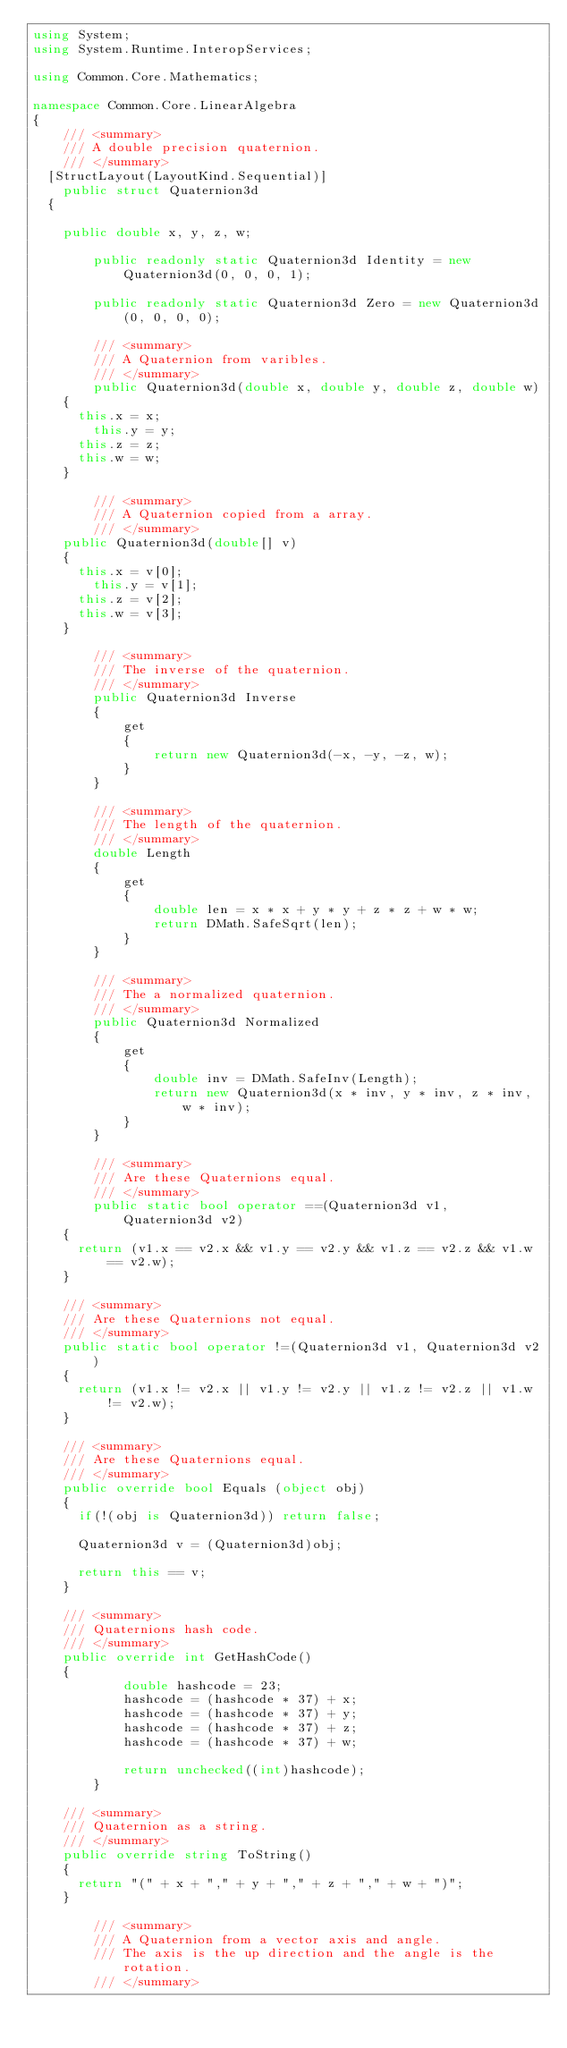<code> <loc_0><loc_0><loc_500><loc_500><_C#_>using System;
using System.Runtime.InteropServices;

using Common.Core.Mathematics;

namespace Common.Core.LinearAlgebra
{
    /// <summary>
    /// A double precision quaternion.
    /// </summary>
	[StructLayout(LayoutKind.Sequential)]
    public struct Quaternion3d
	{
		
		public double x, y, z, w;

        public readonly static Quaternion3d Identity = new Quaternion3d(0, 0, 0, 1);

        public readonly static Quaternion3d Zero = new Quaternion3d(0, 0, 0, 0);

        /// <summary>
        /// A Quaternion from varibles.
        /// </summary>
        public Quaternion3d(double x, double y, double z, double w)
		{
			this.x = x;
		    this.y = y;
			this.z = z;
			this.w = w;
		}

        /// <summary>
        /// A Quaternion copied from a array.
        /// </summary>
		public Quaternion3d(double[] v)
		{
			this.x = v[0];
		    this.y = v[1];
			this.z = v[2];
			this.w = v[3];
		}

        /// <summary>
        /// The inverse of the quaternion.
        /// </summary>
        public Quaternion3d Inverse
        {
            get
            {
                return new Quaternion3d(-x, -y, -z, w);
            }
        }

        /// <summary>
        /// The length of the quaternion.
        /// </summary>
        double Length
        {
            get
            {
                double len = x * x + y * y + z * z + w * w;
                return DMath.SafeSqrt(len);
            }
        }

        /// <summary>
        /// The a normalized quaternion.
        /// </summary>
        public Quaternion3d Normalized
        {
            get
            {
                double inv = DMath.SafeInv(Length);
                return new Quaternion3d(x * inv, y * inv, z * inv, w * inv);
            }
        }

        /// <summary>
        /// Are these Quaternions equal.
        /// </summary>
        public static bool operator ==(Quaternion3d v1, Quaternion3d v2)
		{
			return (v1.x == v2.x && v1.y == v2.y && v1.z == v2.z && v1.w == v2.w);
		}
		
		/// <summary>
		/// Are these Quaternions not equal.
		/// </summary>
		public static bool operator !=(Quaternion3d v1, Quaternion3d v2)
		{
			return (v1.x != v2.x || v1.y != v2.y || v1.z != v2.z || v1.w != v2.w);
		}
		
		/// <summary>
		/// Are these Quaternions equal.
		/// </summary>
		public override bool Equals (object obj)
		{
			if(!(obj is Quaternion3d)) return false;
			
			Quaternion3d v = (Quaternion3d)obj;
			
			return this == v;
		}
		
		/// <summary>
		/// Quaternions hash code. 
		/// </summary>
		public override int GetHashCode()
		{
            double hashcode = 23;
            hashcode = (hashcode * 37) + x;
            hashcode = (hashcode * 37) + y;
            hashcode = (hashcode * 37) + z;
            hashcode = (hashcode * 37) + w;

            return unchecked((int)hashcode);
        }
		
		/// <summary>
		/// Quaternion as a string.
		/// </summary>
		public override string ToString()
		{
			return "(" + x + "," + y + "," + z + "," + w + ")";
		}

        /// <summary>
        /// A Quaternion from a vector axis and angle.
        /// The axis is the up direction and the angle is the rotation.
        /// </summary></code> 